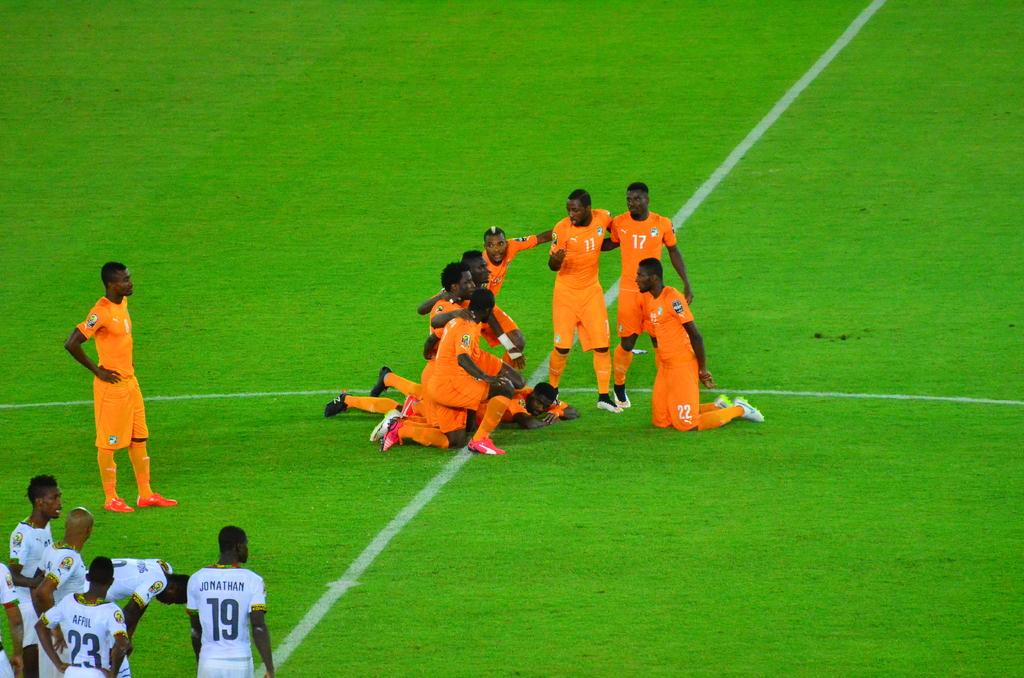What can be seen in the image? There is a group of people in the image. What are the people wearing? Some of the people are wearing orange color jerseys, and some are wearing white color jerseys. What is the ground like in the image? The ground is visible in the image. What type of cherry is being used as a ball in the image? There is no cherry being used as a ball in the image. What time of day is it in the image? The time of day is not mentioned in the image, so we cannot determine if it is afternoon or any other time. 